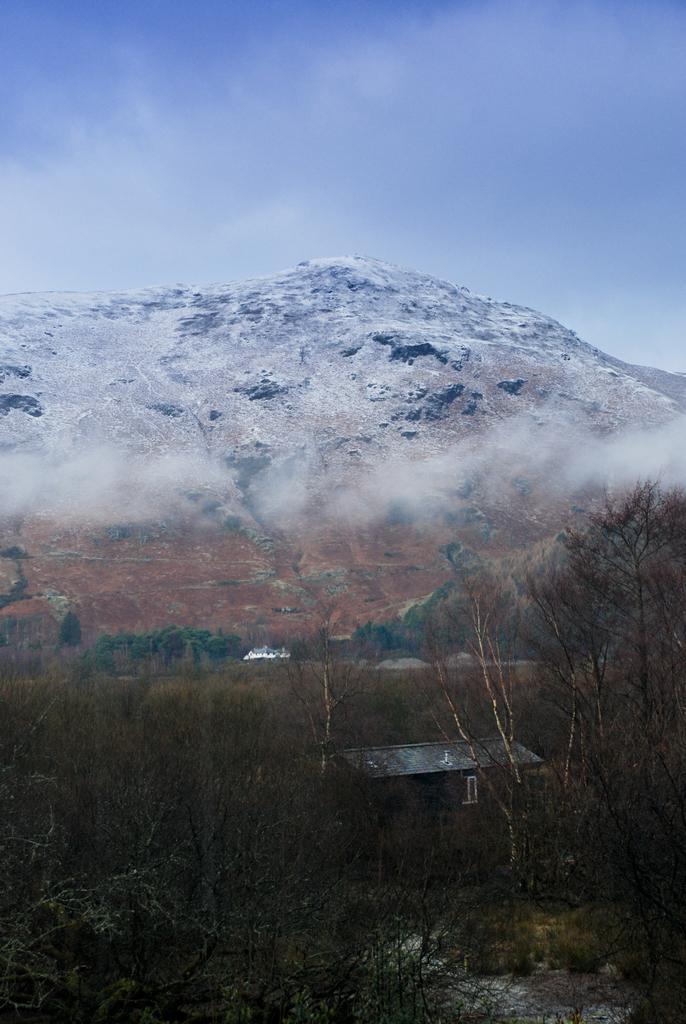Describe this image in one or two sentences. In this image in the foreground there are some trees and house, and in the background there are some mountains and fog. At the bottom there is grass, and at the top of the image there is sky. 